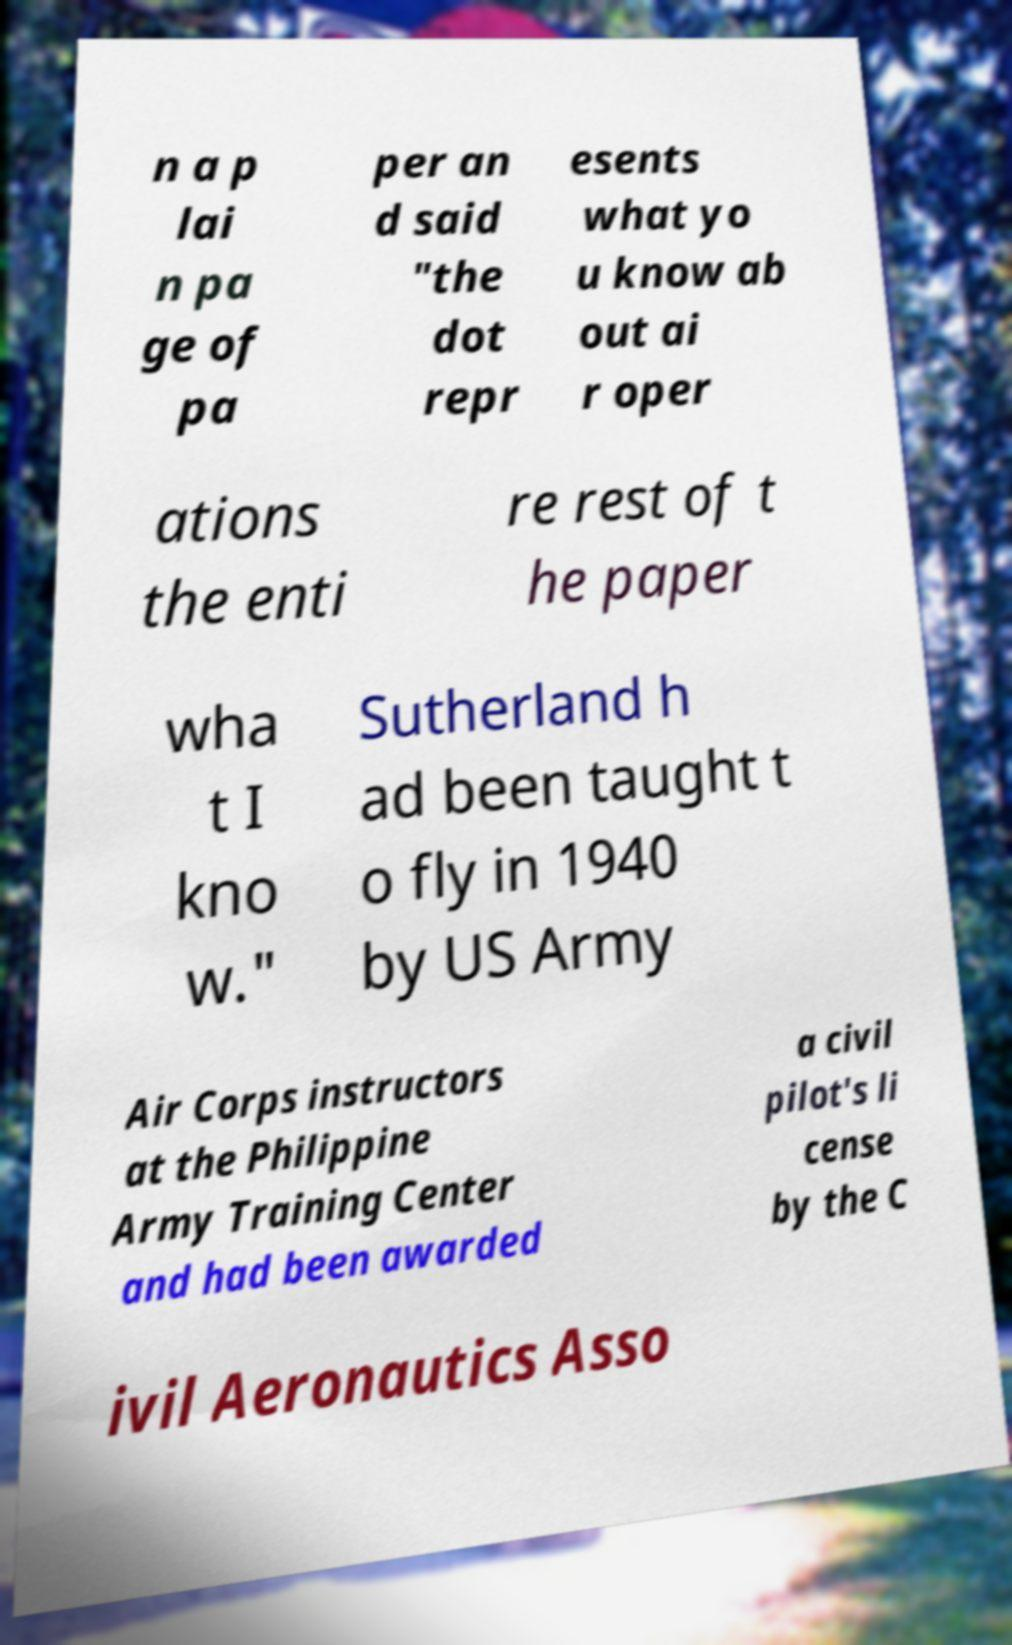Please read and relay the text visible in this image. What does it say? n a p lai n pa ge of pa per an d said "the dot repr esents what yo u know ab out ai r oper ations the enti re rest of t he paper wha t I kno w." Sutherland h ad been taught t o fly in 1940 by US Army Air Corps instructors at the Philippine Army Training Center and had been awarded a civil pilot's li cense by the C ivil Aeronautics Asso 